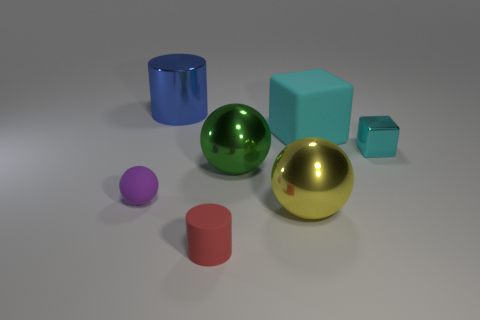Subtract all green metallic spheres. How many spheres are left? 2 Subtract all green spheres. How many spheres are left? 2 Subtract 2 cylinders. How many cylinders are left? 0 Add 2 large cyan cubes. How many objects exist? 9 Subtract all balls. How many objects are left? 4 Subtract all purple cylinders. Subtract all purple spheres. How many cylinders are left? 2 Subtract 0 yellow cubes. How many objects are left? 7 Subtract all purple cylinders. Subtract all big yellow spheres. How many objects are left? 6 Add 5 blue cylinders. How many blue cylinders are left? 6 Add 5 matte blocks. How many matte blocks exist? 6 